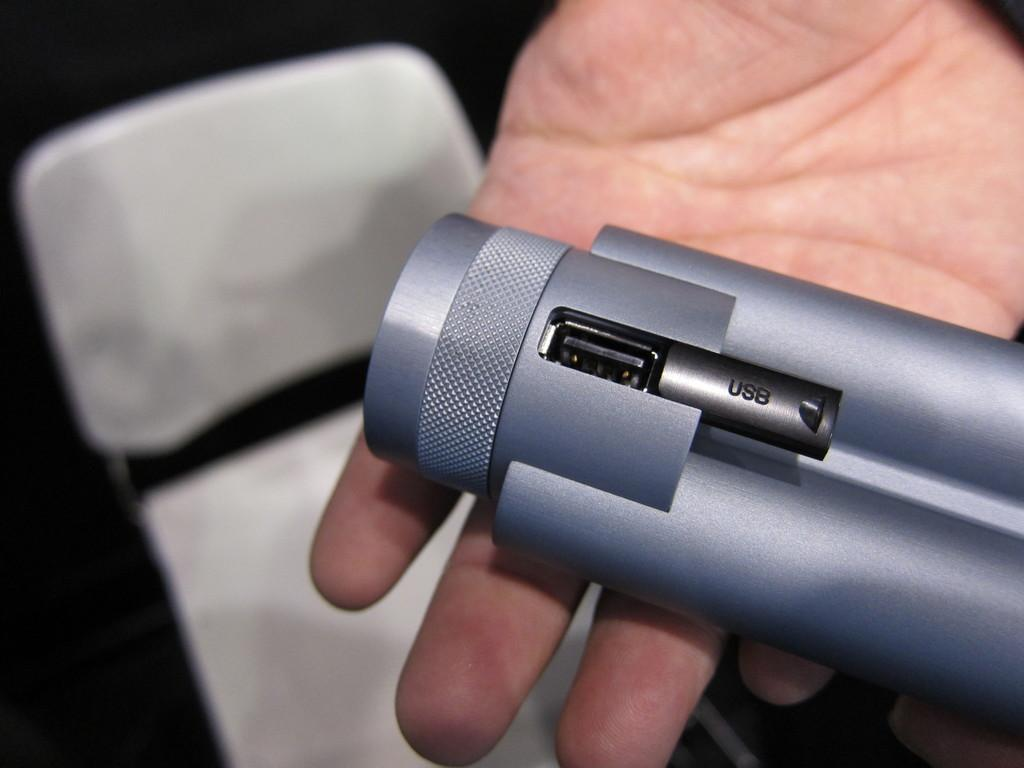What is present in the image? There is a person in the image. What is the person doing in the image? The person is holding an object. Can you describe any other objects in the image? There is a chair in the image. How does the person tie a knot with the object they are holding in the image? There is no indication in the image that the person is tying a knot or that the object is capable of being tied in a knot. 